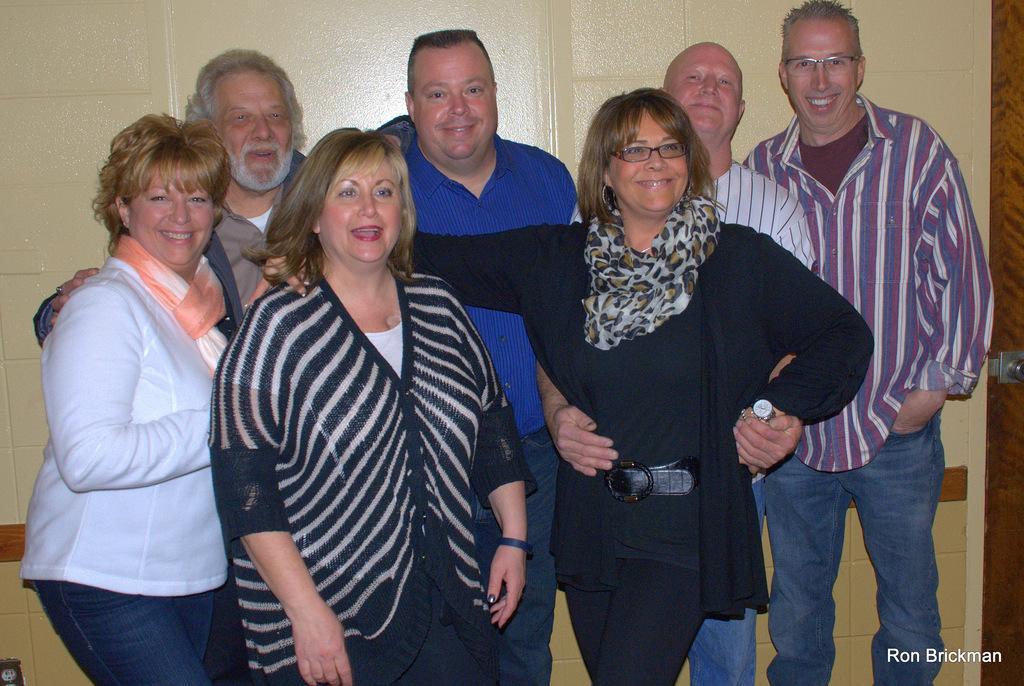Could you give a brief overview of what you see in this image? There are group of people standing and smiling. This looks like a wall. At the right corner of the image, I think this is the door with the door handle. I can see the watermark on the image. 